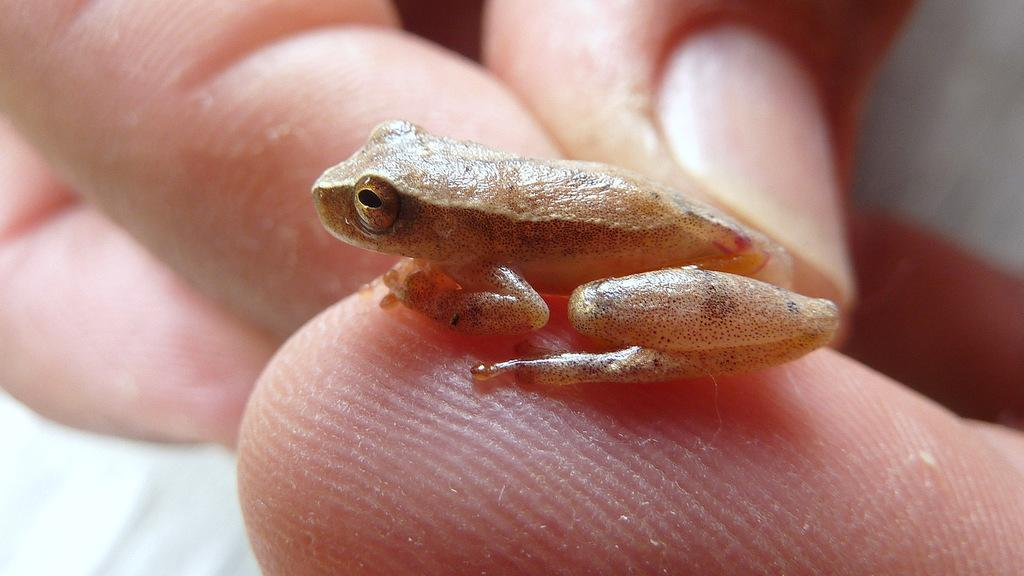What is the main subject of the image? There is a person in the image. What is the person doing in the image? The person's hand is holding a frog. What type of shoes is the person wearing in the image? There is no information about shoes in the image, as the focus is on the person holding a frog. 